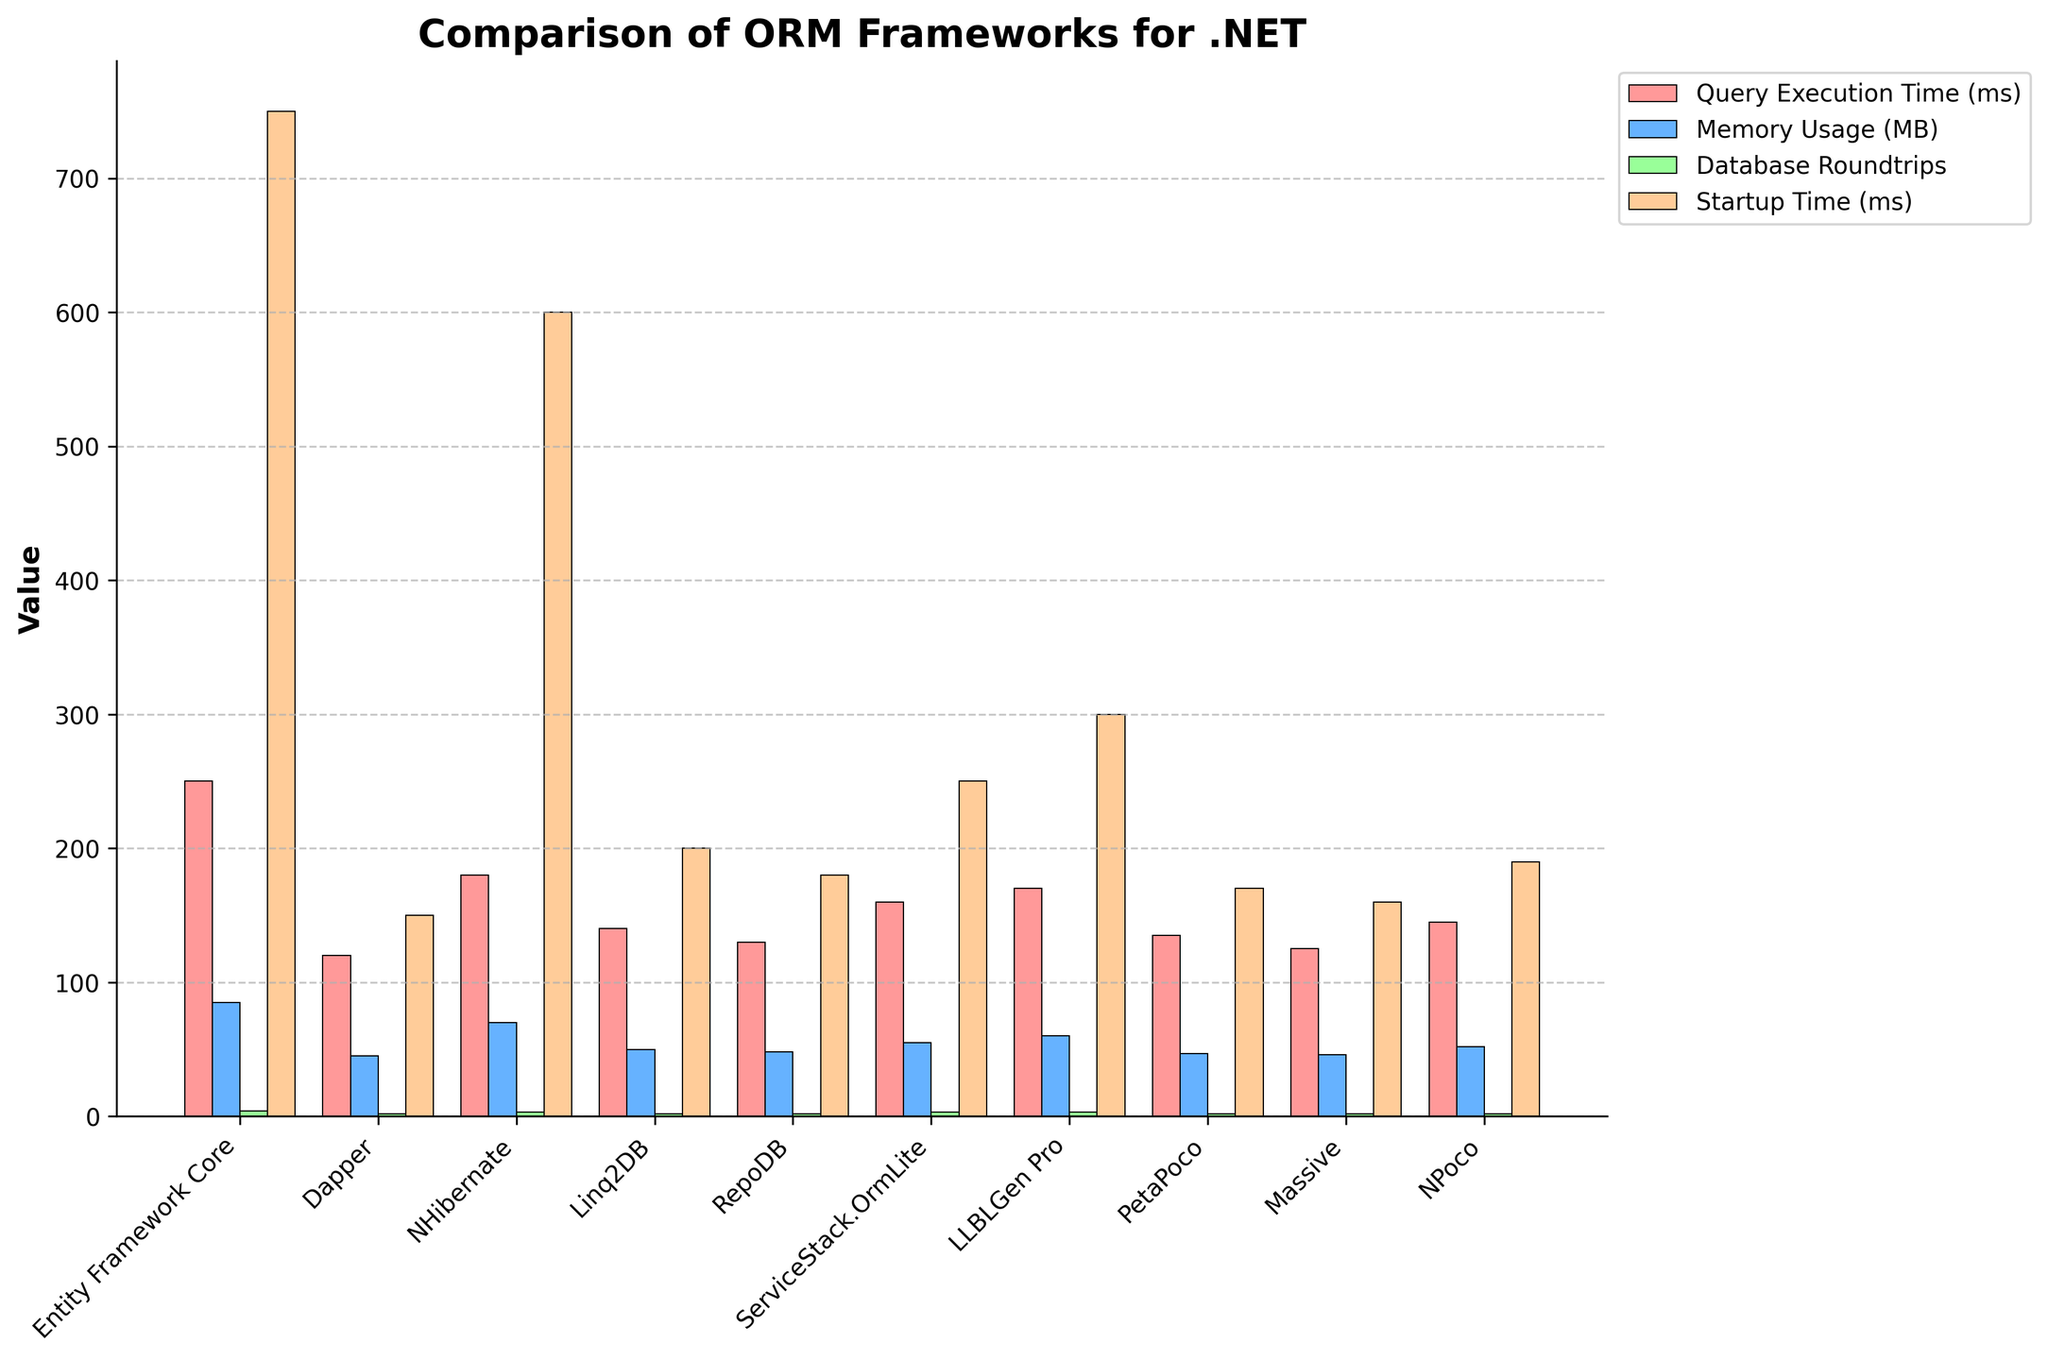Какой фреймворк имеет наименьшее время выполнения запроса? Для определения этого, просто смотрим на высоту столбцов, представляющих время выполнения запроса (Query Execution Time) для каждого фреймворка. Самый низкий столбец соответствует Dapper.
Answer: Dapper Какой фреймворк использует наибольший объем памяти? Для ответа сравниваем высоту столбцов, представляющих использование памяти (Memory Usage), для каждого фреймворка. Наибольший столбец соответствует Entity Framework Core.
Answer: Entity Framework Core Сколько фреймворков имеют время запуска менее 300 мс? Сравниваем высоты столбцов, представляющих время запуска (Startup Time), для всех фреймворков и считаем те, которые ниже отметки 300 мс. Таких фреймворков пять: Dapper, Linq2DB, RepoDB, PetaPoco и Massive.
Answer: 5 Сравните время выполнения запроса у Entity Framework Core и NHibernate. Какое из них меньше и на сколько миллисекунд? Найдем высоты столбцов для времени выполнения запросов (Query Execution Time) у Entity Framework Core и NHibernate. Время выполнения у Entity Framework Core - 250 мс, у NHibernate - 180 мс. Разница составляет 250 - 180 = 70 мс.
Answer: NHibernate на 70 мс Какое общее количество кругов по базе данных сделано всеми фреймворками? Чтобы получить это значение, сложим высоты всех столбцов для количества кругов по базе данных (Database Roundtrips). Эти значения: 4 + 2 + 3 + 2 + 2 + 3 + 3 + 2 + 2 + 2 = 25.
Answer: 25 Какой из фреймворков имеет цвета, счастливого сочетания зеленого и синего в своей визуализации (по времени выполнения запроса и использованию памяти соответственно)? Для определения этого нужно обратиться к цветовому представлению столбцов в легенде: зеленый используется для времени выполнения запроса (Query Execution Time) и синий для использования памяти (Memory Usage). Хотя и не обязательно счастливое сочетание цветов, для точности, массив связан с NHibernate.
Answer: NHibernate Какой фреймворк имеет самый большой разрыв между временем выполнения запроса и временем запуска? Чтобы найти разницу, нужно вычесть время выполнения запроса из времени запуска для каждого фреймворка и найти максимальное значение. Самый большой разрыв у Entity Framework Core: 750 - 250 = 500 мс.
Answer: Entity Framework Core 